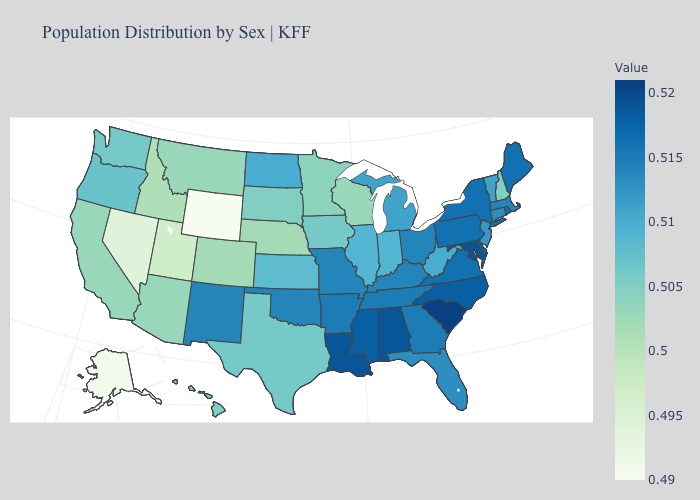Which states have the lowest value in the USA?
Short answer required. Wyoming. Which states have the highest value in the USA?
Give a very brief answer. South Carolina. Does Arkansas have a higher value than South Carolina?
Be succinct. No. Which states have the lowest value in the South?
Write a very short answer. Texas. 